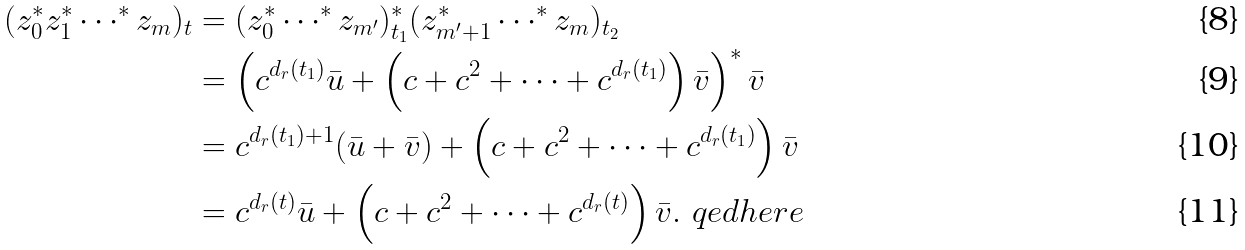<formula> <loc_0><loc_0><loc_500><loc_500>( z _ { 0 } ^ { * } z _ { 1 } ^ { * } \cdots ^ { * } z _ { m } ) _ { t } & = ( z _ { 0 } ^ { * } \cdots ^ { * } z _ { m ^ { \prime } } ) _ { t _ { 1 } } ^ { * } ( z _ { m ^ { \prime } + 1 } ^ { * } \cdots ^ { * } z _ { m } ) _ { t _ { 2 } } \\ & = \left ( c ^ { d _ { r } ( t _ { 1 } ) } \bar { u } + \left ( c + c ^ { 2 } + \cdots + c ^ { d _ { r } ( t _ { 1 } ) } \right ) \bar { v } \right ) ^ { * } \bar { v } \\ & = c ^ { d _ { r } ( t _ { 1 } ) + 1 } ( \bar { u } + \bar { v } ) + \left ( c + c ^ { 2 } + \cdots + c ^ { d _ { r } ( t _ { 1 } ) } \right ) \bar { v } \\ & = c ^ { d _ { r } ( t ) } \bar { u } + \left ( c + c ^ { 2 } + \cdots + c ^ { d _ { r } ( t ) } \right ) \bar { v } . \ q e d h e r e</formula> 